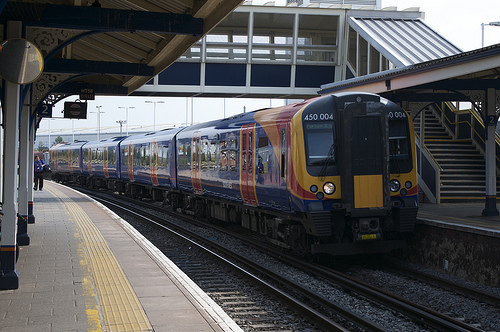Please provide the bounding box coordinate of the region this sentence describes: Catwalk over train rail. The area representing the catwalk over the train rail is found within the coordinates [0.3, 0.18, 0.88, 0.36], capturing the elevated walkway across the railway tracks that facilitate maintenance or access. 